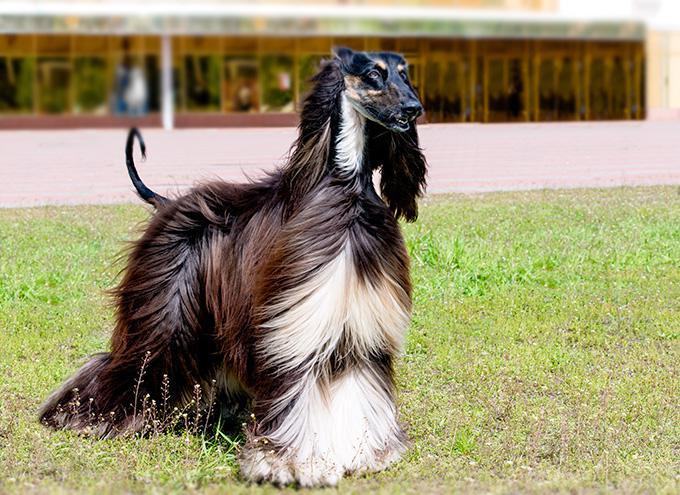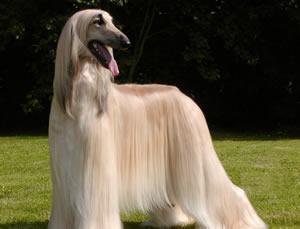The first image is the image on the left, the second image is the image on the right. Examine the images to the left and right. Is the description "The dog in both images are standing in the grass." accurate? Answer yes or no. Yes. The first image is the image on the left, the second image is the image on the right. Assess this claim about the two images: "The dogs in the two images have their bodies turned toward each other, and their heads both turned in the same direction.". Correct or not? Answer yes or no. Yes. 